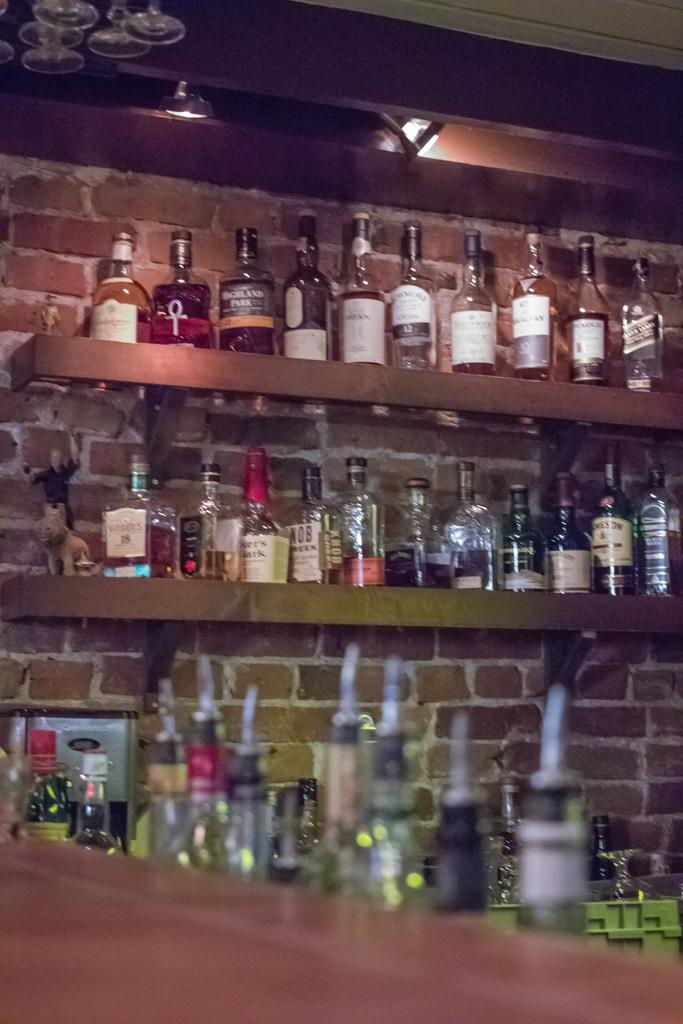What type of bottles can be seen in the image? There are wine bottles in the image. How are the wine bottles arranged in the image? The wine bottles are arranged in shelves. Can you see any toads sitting on the wine bottles in the image? There are no toads present in the image; it only features wine bottles arranged in shelves. 